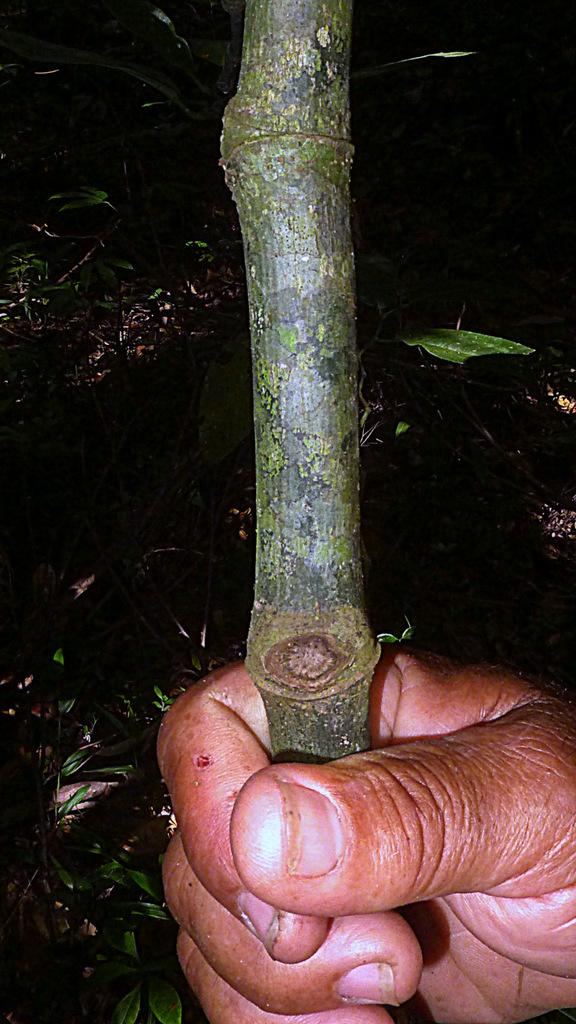What part of a person can be seen in the image? A person's hand is visible in the image. What is the person holding in the image? The person is holding a stick. What type of vegetation is visible in the background of the image? There are plants in the background of the image. How many cows are visible in the image? There are no cows present in the image. What type of tree is in the background of the image? There is no tree visible in the image; only plants are present in the background. 